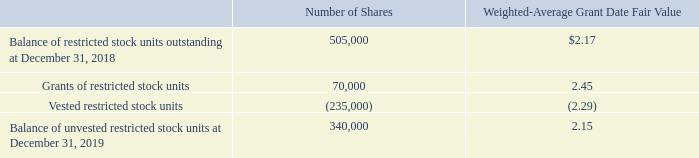NOTE F – STOCKHOLDERS’ EQUITY (CONTINUED)
A summary of restricted stock units granted during the year ended December 31, 2019 is as follows (each restricted stock unit represents the contingent right to receive one share of the Company’s common stock):
Restricted stock unit compensation expense was $567,000 for the year ended December 31, 2019 and $687,000 for the year ended December 31, 2018.
The Company has an aggregate of $232,000 of unrecognized restricted stock unit compensation expense as of December 31, 2019 to be expensed over a weighted average period of 1.2 years.
Which note does the stockholders equity information belong to? Note f. What does each restricted stock unit represent? Each restricted stock unit represents the contingent right to receive one share of the company’s common stock. How many years are the unrecognized restricted stock unit compensation expensed over? 1.2. What was the total restricted stock unit compensation expense for the years 2018 and 2019? 567,000 + 687,000  
Answer: 1254000. What was the percentage change in balance of restricted stock units outstanding from 2018 to 2019?
Answer scale should be: percent. (340,000 - 505,000) / 505,000 
Answer: -32.67. What is the difference in weighted-average grant date fair value for grants of restricted stock units and vested restricted stock units? 2.45 - (-2.29) 
Answer: 4.74. 